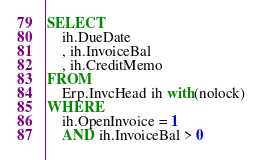Convert code to text. <code><loc_0><loc_0><loc_500><loc_500><_SQL_>SELECT
	ih.DueDate
	, ih.InvoiceBal
	, ih.CreditMemo
FROM
	Erp.InvcHead ih with(nolock)
WHERE
	ih.OpenInvoice = 1
	AND ih.InvoiceBal > 0</code> 